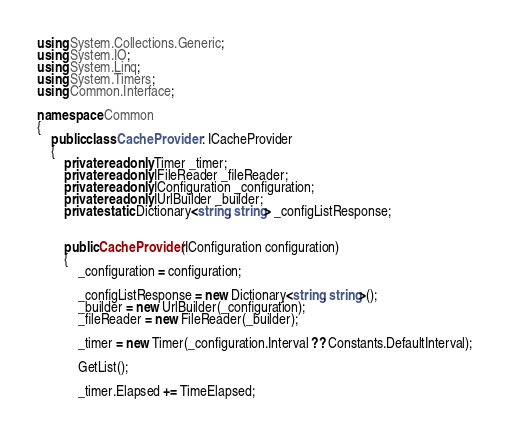<code> <loc_0><loc_0><loc_500><loc_500><_C#_>using System.Collections.Generic;
using System.IO;
using System.Linq;
using System.Timers;
using Common.Interface;

namespace Common
{
    public class CacheProvider : ICacheProvider
    {
        private readonly Timer _timer;
        private readonly IFileReader _fileReader;
        private readonly IConfiguration _configuration;
        private readonly IUrlBuilder _builder;
        private static Dictionary<string, string> _configListResponse;


        public CacheProvider(IConfiguration configuration)
        {
            _configuration = configuration;

            _configListResponse = new Dictionary<string, string>();
            _builder = new UrlBuilder(_configuration);
            _fileReader = new FileReader(_builder);

            _timer = new Timer(_configuration.Interval ?? Constants.DefaultInterval);

            GetList();

            _timer.Elapsed += TimeElapsed;
</code> 